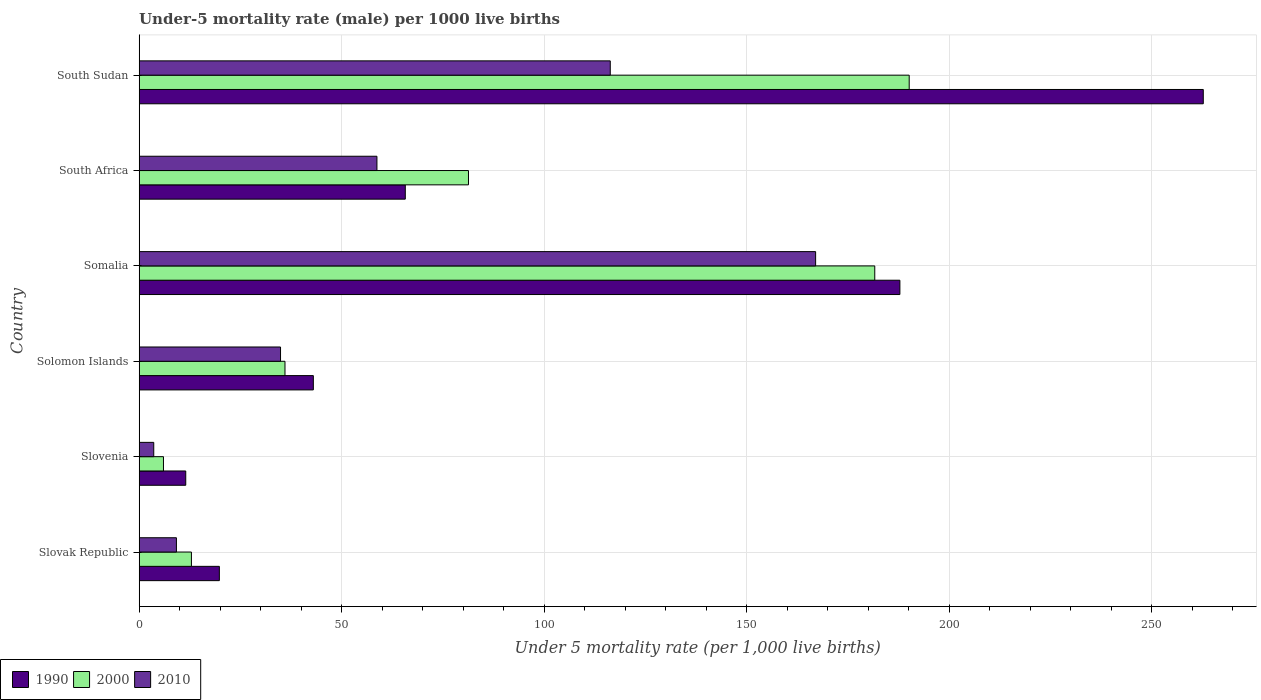How many groups of bars are there?
Offer a very short reply. 6. Are the number of bars on each tick of the Y-axis equal?
Offer a terse response. Yes. How many bars are there on the 1st tick from the top?
Offer a terse response. 3. How many bars are there on the 2nd tick from the bottom?
Offer a terse response. 3. What is the label of the 5th group of bars from the top?
Give a very brief answer. Slovenia. What is the under-five mortality rate in 2000 in Somalia?
Your response must be concise. 181.6. Across all countries, what is the maximum under-five mortality rate in 2000?
Make the answer very short. 190.1. In which country was the under-five mortality rate in 2000 maximum?
Ensure brevity in your answer.  South Sudan. In which country was the under-five mortality rate in 2010 minimum?
Offer a terse response. Slovenia. What is the total under-five mortality rate in 2010 in the graph?
Make the answer very short. 389.7. What is the difference between the under-five mortality rate in 2000 in Slovenia and that in South Sudan?
Keep it short and to the point. -184.1. What is the difference between the under-five mortality rate in 2000 in Slovak Republic and the under-five mortality rate in 1990 in South Sudan?
Your answer should be very brief. -249.8. What is the average under-five mortality rate in 1990 per country?
Your answer should be compact. 98.42. What is the difference between the under-five mortality rate in 1990 and under-five mortality rate in 2010 in Slovak Republic?
Provide a succinct answer. 10.6. What is the ratio of the under-five mortality rate in 2000 in Slovenia to that in South Sudan?
Your answer should be compact. 0.03. What is the difference between the highest and the second highest under-five mortality rate in 2010?
Your answer should be compact. 50.7. What is the difference between the highest and the lowest under-five mortality rate in 1990?
Your response must be concise. 251.2. In how many countries, is the under-five mortality rate in 1990 greater than the average under-five mortality rate in 1990 taken over all countries?
Provide a short and direct response. 2. Is the sum of the under-five mortality rate in 2000 in South Africa and South Sudan greater than the maximum under-five mortality rate in 1990 across all countries?
Offer a terse response. Yes. What does the 3rd bar from the top in Somalia represents?
Ensure brevity in your answer.  1990. How many bars are there?
Offer a terse response. 18. Are all the bars in the graph horizontal?
Provide a succinct answer. Yes. Are the values on the major ticks of X-axis written in scientific E-notation?
Keep it short and to the point. No. How many legend labels are there?
Your response must be concise. 3. How are the legend labels stacked?
Provide a succinct answer. Horizontal. What is the title of the graph?
Give a very brief answer. Under-5 mortality rate (male) per 1000 live births. Does "1962" appear as one of the legend labels in the graph?
Give a very brief answer. No. What is the label or title of the X-axis?
Make the answer very short. Under 5 mortality rate (per 1,0 live births). What is the Under 5 mortality rate (per 1,000 live births) in 1990 in Slovak Republic?
Give a very brief answer. 19.8. What is the Under 5 mortality rate (per 1,000 live births) in 2000 in Slovak Republic?
Offer a terse response. 12.9. What is the Under 5 mortality rate (per 1,000 live births) of 2010 in Slovak Republic?
Provide a succinct answer. 9.2. What is the Under 5 mortality rate (per 1,000 live births) in 1990 in Slovenia?
Your answer should be compact. 11.5. What is the Under 5 mortality rate (per 1,000 live births) in 2010 in Slovenia?
Your answer should be very brief. 3.6. What is the Under 5 mortality rate (per 1,000 live births) of 1990 in Solomon Islands?
Provide a short and direct response. 43. What is the Under 5 mortality rate (per 1,000 live births) in 2010 in Solomon Islands?
Your answer should be compact. 34.9. What is the Under 5 mortality rate (per 1,000 live births) in 1990 in Somalia?
Provide a succinct answer. 187.8. What is the Under 5 mortality rate (per 1,000 live births) of 2000 in Somalia?
Offer a very short reply. 181.6. What is the Under 5 mortality rate (per 1,000 live births) of 2010 in Somalia?
Your answer should be compact. 167. What is the Under 5 mortality rate (per 1,000 live births) of 1990 in South Africa?
Provide a short and direct response. 65.7. What is the Under 5 mortality rate (per 1,000 live births) of 2000 in South Africa?
Make the answer very short. 81.3. What is the Under 5 mortality rate (per 1,000 live births) of 2010 in South Africa?
Your answer should be compact. 58.7. What is the Under 5 mortality rate (per 1,000 live births) in 1990 in South Sudan?
Ensure brevity in your answer.  262.7. What is the Under 5 mortality rate (per 1,000 live births) of 2000 in South Sudan?
Keep it short and to the point. 190.1. What is the Under 5 mortality rate (per 1,000 live births) in 2010 in South Sudan?
Your answer should be very brief. 116.3. Across all countries, what is the maximum Under 5 mortality rate (per 1,000 live births) of 1990?
Offer a terse response. 262.7. Across all countries, what is the maximum Under 5 mortality rate (per 1,000 live births) in 2000?
Give a very brief answer. 190.1. Across all countries, what is the maximum Under 5 mortality rate (per 1,000 live births) of 2010?
Offer a terse response. 167. Across all countries, what is the minimum Under 5 mortality rate (per 1,000 live births) in 2000?
Keep it short and to the point. 6. Across all countries, what is the minimum Under 5 mortality rate (per 1,000 live births) in 2010?
Ensure brevity in your answer.  3.6. What is the total Under 5 mortality rate (per 1,000 live births) in 1990 in the graph?
Make the answer very short. 590.5. What is the total Under 5 mortality rate (per 1,000 live births) in 2000 in the graph?
Offer a very short reply. 507.9. What is the total Under 5 mortality rate (per 1,000 live births) in 2010 in the graph?
Make the answer very short. 389.7. What is the difference between the Under 5 mortality rate (per 1,000 live births) of 1990 in Slovak Republic and that in Slovenia?
Your response must be concise. 8.3. What is the difference between the Under 5 mortality rate (per 1,000 live births) of 2000 in Slovak Republic and that in Slovenia?
Keep it short and to the point. 6.9. What is the difference between the Under 5 mortality rate (per 1,000 live births) in 2010 in Slovak Republic and that in Slovenia?
Your response must be concise. 5.6. What is the difference between the Under 5 mortality rate (per 1,000 live births) in 1990 in Slovak Republic and that in Solomon Islands?
Keep it short and to the point. -23.2. What is the difference between the Under 5 mortality rate (per 1,000 live births) in 2000 in Slovak Republic and that in Solomon Islands?
Ensure brevity in your answer.  -23.1. What is the difference between the Under 5 mortality rate (per 1,000 live births) in 2010 in Slovak Republic and that in Solomon Islands?
Ensure brevity in your answer.  -25.7. What is the difference between the Under 5 mortality rate (per 1,000 live births) in 1990 in Slovak Republic and that in Somalia?
Offer a terse response. -168. What is the difference between the Under 5 mortality rate (per 1,000 live births) of 2000 in Slovak Republic and that in Somalia?
Offer a terse response. -168.7. What is the difference between the Under 5 mortality rate (per 1,000 live births) of 2010 in Slovak Republic and that in Somalia?
Ensure brevity in your answer.  -157.8. What is the difference between the Under 5 mortality rate (per 1,000 live births) of 1990 in Slovak Republic and that in South Africa?
Provide a short and direct response. -45.9. What is the difference between the Under 5 mortality rate (per 1,000 live births) of 2000 in Slovak Republic and that in South Africa?
Keep it short and to the point. -68.4. What is the difference between the Under 5 mortality rate (per 1,000 live births) of 2010 in Slovak Republic and that in South Africa?
Your answer should be very brief. -49.5. What is the difference between the Under 5 mortality rate (per 1,000 live births) in 1990 in Slovak Republic and that in South Sudan?
Your response must be concise. -242.9. What is the difference between the Under 5 mortality rate (per 1,000 live births) in 2000 in Slovak Republic and that in South Sudan?
Make the answer very short. -177.2. What is the difference between the Under 5 mortality rate (per 1,000 live births) in 2010 in Slovak Republic and that in South Sudan?
Offer a terse response. -107.1. What is the difference between the Under 5 mortality rate (per 1,000 live births) of 1990 in Slovenia and that in Solomon Islands?
Make the answer very short. -31.5. What is the difference between the Under 5 mortality rate (per 1,000 live births) of 2000 in Slovenia and that in Solomon Islands?
Your answer should be compact. -30. What is the difference between the Under 5 mortality rate (per 1,000 live births) of 2010 in Slovenia and that in Solomon Islands?
Your answer should be compact. -31.3. What is the difference between the Under 5 mortality rate (per 1,000 live births) in 1990 in Slovenia and that in Somalia?
Your response must be concise. -176.3. What is the difference between the Under 5 mortality rate (per 1,000 live births) of 2000 in Slovenia and that in Somalia?
Provide a succinct answer. -175.6. What is the difference between the Under 5 mortality rate (per 1,000 live births) in 2010 in Slovenia and that in Somalia?
Provide a short and direct response. -163.4. What is the difference between the Under 5 mortality rate (per 1,000 live births) in 1990 in Slovenia and that in South Africa?
Your response must be concise. -54.2. What is the difference between the Under 5 mortality rate (per 1,000 live births) of 2000 in Slovenia and that in South Africa?
Your response must be concise. -75.3. What is the difference between the Under 5 mortality rate (per 1,000 live births) of 2010 in Slovenia and that in South Africa?
Your response must be concise. -55.1. What is the difference between the Under 5 mortality rate (per 1,000 live births) of 1990 in Slovenia and that in South Sudan?
Keep it short and to the point. -251.2. What is the difference between the Under 5 mortality rate (per 1,000 live births) in 2000 in Slovenia and that in South Sudan?
Make the answer very short. -184.1. What is the difference between the Under 5 mortality rate (per 1,000 live births) of 2010 in Slovenia and that in South Sudan?
Your answer should be very brief. -112.7. What is the difference between the Under 5 mortality rate (per 1,000 live births) of 1990 in Solomon Islands and that in Somalia?
Make the answer very short. -144.8. What is the difference between the Under 5 mortality rate (per 1,000 live births) in 2000 in Solomon Islands and that in Somalia?
Offer a terse response. -145.6. What is the difference between the Under 5 mortality rate (per 1,000 live births) of 2010 in Solomon Islands and that in Somalia?
Ensure brevity in your answer.  -132.1. What is the difference between the Under 5 mortality rate (per 1,000 live births) in 1990 in Solomon Islands and that in South Africa?
Make the answer very short. -22.7. What is the difference between the Under 5 mortality rate (per 1,000 live births) in 2000 in Solomon Islands and that in South Africa?
Your answer should be very brief. -45.3. What is the difference between the Under 5 mortality rate (per 1,000 live births) in 2010 in Solomon Islands and that in South Africa?
Offer a terse response. -23.8. What is the difference between the Under 5 mortality rate (per 1,000 live births) in 1990 in Solomon Islands and that in South Sudan?
Give a very brief answer. -219.7. What is the difference between the Under 5 mortality rate (per 1,000 live births) in 2000 in Solomon Islands and that in South Sudan?
Offer a very short reply. -154.1. What is the difference between the Under 5 mortality rate (per 1,000 live births) in 2010 in Solomon Islands and that in South Sudan?
Your answer should be compact. -81.4. What is the difference between the Under 5 mortality rate (per 1,000 live births) of 1990 in Somalia and that in South Africa?
Ensure brevity in your answer.  122.1. What is the difference between the Under 5 mortality rate (per 1,000 live births) in 2000 in Somalia and that in South Africa?
Your response must be concise. 100.3. What is the difference between the Under 5 mortality rate (per 1,000 live births) in 2010 in Somalia and that in South Africa?
Keep it short and to the point. 108.3. What is the difference between the Under 5 mortality rate (per 1,000 live births) in 1990 in Somalia and that in South Sudan?
Offer a terse response. -74.9. What is the difference between the Under 5 mortality rate (per 1,000 live births) of 2000 in Somalia and that in South Sudan?
Offer a terse response. -8.5. What is the difference between the Under 5 mortality rate (per 1,000 live births) in 2010 in Somalia and that in South Sudan?
Provide a succinct answer. 50.7. What is the difference between the Under 5 mortality rate (per 1,000 live births) in 1990 in South Africa and that in South Sudan?
Your answer should be compact. -197. What is the difference between the Under 5 mortality rate (per 1,000 live births) in 2000 in South Africa and that in South Sudan?
Offer a terse response. -108.8. What is the difference between the Under 5 mortality rate (per 1,000 live births) of 2010 in South Africa and that in South Sudan?
Offer a terse response. -57.6. What is the difference between the Under 5 mortality rate (per 1,000 live births) in 1990 in Slovak Republic and the Under 5 mortality rate (per 1,000 live births) in 2000 in Slovenia?
Your answer should be very brief. 13.8. What is the difference between the Under 5 mortality rate (per 1,000 live births) of 1990 in Slovak Republic and the Under 5 mortality rate (per 1,000 live births) of 2000 in Solomon Islands?
Provide a short and direct response. -16.2. What is the difference between the Under 5 mortality rate (per 1,000 live births) in 1990 in Slovak Republic and the Under 5 mortality rate (per 1,000 live births) in 2010 in Solomon Islands?
Your answer should be very brief. -15.1. What is the difference between the Under 5 mortality rate (per 1,000 live births) in 2000 in Slovak Republic and the Under 5 mortality rate (per 1,000 live births) in 2010 in Solomon Islands?
Offer a terse response. -22. What is the difference between the Under 5 mortality rate (per 1,000 live births) in 1990 in Slovak Republic and the Under 5 mortality rate (per 1,000 live births) in 2000 in Somalia?
Ensure brevity in your answer.  -161.8. What is the difference between the Under 5 mortality rate (per 1,000 live births) of 1990 in Slovak Republic and the Under 5 mortality rate (per 1,000 live births) of 2010 in Somalia?
Provide a succinct answer. -147.2. What is the difference between the Under 5 mortality rate (per 1,000 live births) of 2000 in Slovak Republic and the Under 5 mortality rate (per 1,000 live births) of 2010 in Somalia?
Provide a short and direct response. -154.1. What is the difference between the Under 5 mortality rate (per 1,000 live births) in 1990 in Slovak Republic and the Under 5 mortality rate (per 1,000 live births) in 2000 in South Africa?
Give a very brief answer. -61.5. What is the difference between the Under 5 mortality rate (per 1,000 live births) of 1990 in Slovak Republic and the Under 5 mortality rate (per 1,000 live births) of 2010 in South Africa?
Make the answer very short. -38.9. What is the difference between the Under 5 mortality rate (per 1,000 live births) of 2000 in Slovak Republic and the Under 5 mortality rate (per 1,000 live births) of 2010 in South Africa?
Your answer should be very brief. -45.8. What is the difference between the Under 5 mortality rate (per 1,000 live births) in 1990 in Slovak Republic and the Under 5 mortality rate (per 1,000 live births) in 2000 in South Sudan?
Your answer should be compact. -170.3. What is the difference between the Under 5 mortality rate (per 1,000 live births) in 1990 in Slovak Republic and the Under 5 mortality rate (per 1,000 live births) in 2010 in South Sudan?
Offer a terse response. -96.5. What is the difference between the Under 5 mortality rate (per 1,000 live births) of 2000 in Slovak Republic and the Under 5 mortality rate (per 1,000 live births) of 2010 in South Sudan?
Offer a very short reply. -103.4. What is the difference between the Under 5 mortality rate (per 1,000 live births) of 1990 in Slovenia and the Under 5 mortality rate (per 1,000 live births) of 2000 in Solomon Islands?
Your response must be concise. -24.5. What is the difference between the Under 5 mortality rate (per 1,000 live births) of 1990 in Slovenia and the Under 5 mortality rate (per 1,000 live births) of 2010 in Solomon Islands?
Make the answer very short. -23.4. What is the difference between the Under 5 mortality rate (per 1,000 live births) of 2000 in Slovenia and the Under 5 mortality rate (per 1,000 live births) of 2010 in Solomon Islands?
Offer a very short reply. -28.9. What is the difference between the Under 5 mortality rate (per 1,000 live births) in 1990 in Slovenia and the Under 5 mortality rate (per 1,000 live births) in 2000 in Somalia?
Your answer should be very brief. -170.1. What is the difference between the Under 5 mortality rate (per 1,000 live births) in 1990 in Slovenia and the Under 5 mortality rate (per 1,000 live births) in 2010 in Somalia?
Give a very brief answer. -155.5. What is the difference between the Under 5 mortality rate (per 1,000 live births) of 2000 in Slovenia and the Under 5 mortality rate (per 1,000 live births) of 2010 in Somalia?
Provide a succinct answer. -161. What is the difference between the Under 5 mortality rate (per 1,000 live births) in 1990 in Slovenia and the Under 5 mortality rate (per 1,000 live births) in 2000 in South Africa?
Give a very brief answer. -69.8. What is the difference between the Under 5 mortality rate (per 1,000 live births) of 1990 in Slovenia and the Under 5 mortality rate (per 1,000 live births) of 2010 in South Africa?
Make the answer very short. -47.2. What is the difference between the Under 5 mortality rate (per 1,000 live births) in 2000 in Slovenia and the Under 5 mortality rate (per 1,000 live births) in 2010 in South Africa?
Keep it short and to the point. -52.7. What is the difference between the Under 5 mortality rate (per 1,000 live births) in 1990 in Slovenia and the Under 5 mortality rate (per 1,000 live births) in 2000 in South Sudan?
Offer a terse response. -178.6. What is the difference between the Under 5 mortality rate (per 1,000 live births) of 1990 in Slovenia and the Under 5 mortality rate (per 1,000 live births) of 2010 in South Sudan?
Make the answer very short. -104.8. What is the difference between the Under 5 mortality rate (per 1,000 live births) in 2000 in Slovenia and the Under 5 mortality rate (per 1,000 live births) in 2010 in South Sudan?
Your answer should be very brief. -110.3. What is the difference between the Under 5 mortality rate (per 1,000 live births) of 1990 in Solomon Islands and the Under 5 mortality rate (per 1,000 live births) of 2000 in Somalia?
Ensure brevity in your answer.  -138.6. What is the difference between the Under 5 mortality rate (per 1,000 live births) of 1990 in Solomon Islands and the Under 5 mortality rate (per 1,000 live births) of 2010 in Somalia?
Your answer should be very brief. -124. What is the difference between the Under 5 mortality rate (per 1,000 live births) of 2000 in Solomon Islands and the Under 5 mortality rate (per 1,000 live births) of 2010 in Somalia?
Your response must be concise. -131. What is the difference between the Under 5 mortality rate (per 1,000 live births) in 1990 in Solomon Islands and the Under 5 mortality rate (per 1,000 live births) in 2000 in South Africa?
Ensure brevity in your answer.  -38.3. What is the difference between the Under 5 mortality rate (per 1,000 live births) of 1990 in Solomon Islands and the Under 5 mortality rate (per 1,000 live births) of 2010 in South Africa?
Offer a terse response. -15.7. What is the difference between the Under 5 mortality rate (per 1,000 live births) of 2000 in Solomon Islands and the Under 5 mortality rate (per 1,000 live births) of 2010 in South Africa?
Keep it short and to the point. -22.7. What is the difference between the Under 5 mortality rate (per 1,000 live births) of 1990 in Solomon Islands and the Under 5 mortality rate (per 1,000 live births) of 2000 in South Sudan?
Offer a terse response. -147.1. What is the difference between the Under 5 mortality rate (per 1,000 live births) of 1990 in Solomon Islands and the Under 5 mortality rate (per 1,000 live births) of 2010 in South Sudan?
Your response must be concise. -73.3. What is the difference between the Under 5 mortality rate (per 1,000 live births) in 2000 in Solomon Islands and the Under 5 mortality rate (per 1,000 live births) in 2010 in South Sudan?
Offer a very short reply. -80.3. What is the difference between the Under 5 mortality rate (per 1,000 live births) in 1990 in Somalia and the Under 5 mortality rate (per 1,000 live births) in 2000 in South Africa?
Your answer should be very brief. 106.5. What is the difference between the Under 5 mortality rate (per 1,000 live births) of 1990 in Somalia and the Under 5 mortality rate (per 1,000 live births) of 2010 in South Africa?
Make the answer very short. 129.1. What is the difference between the Under 5 mortality rate (per 1,000 live births) in 2000 in Somalia and the Under 5 mortality rate (per 1,000 live births) in 2010 in South Africa?
Ensure brevity in your answer.  122.9. What is the difference between the Under 5 mortality rate (per 1,000 live births) of 1990 in Somalia and the Under 5 mortality rate (per 1,000 live births) of 2000 in South Sudan?
Ensure brevity in your answer.  -2.3. What is the difference between the Under 5 mortality rate (per 1,000 live births) in 1990 in Somalia and the Under 5 mortality rate (per 1,000 live births) in 2010 in South Sudan?
Provide a succinct answer. 71.5. What is the difference between the Under 5 mortality rate (per 1,000 live births) in 2000 in Somalia and the Under 5 mortality rate (per 1,000 live births) in 2010 in South Sudan?
Provide a short and direct response. 65.3. What is the difference between the Under 5 mortality rate (per 1,000 live births) of 1990 in South Africa and the Under 5 mortality rate (per 1,000 live births) of 2000 in South Sudan?
Provide a succinct answer. -124.4. What is the difference between the Under 5 mortality rate (per 1,000 live births) in 1990 in South Africa and the Under 5 mortality rate (per 1,000 live births) in 2010 in South Sudan?
Make the answer very short. -50.6. What is the difference between the Under 5 mortality rate (per 1,000 live births) of 2000 in South Africa and the Under 5 mortality rate (per 1,000 live births) of 2010 in South Sudan?
Provide a short and direct response. -35. What is the average Under 5 mortality rate (per 1,000 live births) of 1990 per country?
Offer a terse response. 98.42. What is the average Under 5 mortality rate (per 1,000 live births) in 2000 per country?
Give a very brief answer. 84.65. What is the average Under 5 mortality rate (per 1,000 live births) in 2010 per country?
Offer a very short reply. 64.95. What is the difference between the Under 5 mortality rate (per 1,000 live births) in 2000 and Under 5 mortality rate (per 1,000 live births) in 2010 in Slovenia?
Provide a short and direct response. 2.4. What is the difference between the Under 5 mortality rate (per 1,000 live births) of 2000 and Under 5 mortality rate (per 1,000 live births) of 2010 in Solomon Islands?
Your answer should be compact. 1.1. What is the difference between the Under 5 mortality rate (per 1,000 live births) of 1990 and Under 5 mortality rate (per 1,000 live births) of 2010 in Somalia?
Make the answer very short. 20.8. What is the difference between the Under 5 mortality rate (per 1,000 live births) in 1990 and Under 5 mortality rate (per 1,000 live births) in 2000 in South Africa?
Provide a succinct answer. -15.6. What is the difference between the Under 5 mortality rate (per 1,000 live births) in 1990 and Under 5 mortality rate (per 1,000 live births) in 2010 in South Africa?
Keep it short and to the point. 7. What is the difference between the Under 5 mortality rate (per 1,000 live births) in 2000 and Under 5 mortality rate (per 1,000 live births) in 2010 in South Africa?
Ensure brevity in your answer.  22.6. What is the difference between the Under 5 mortality rate (per 1,000 live births) of 1990 and Under 5 mortality rate (per 1,000 live births) of 2000 in South Sudan?
Your answer should be compact. 72.6. What is the difference between the Under 5 mortality rate (per 1,000 live births) of 1990 and Under 5 mortality rate (per 1,000 live births) of 2010 in South Sudan?
Offer a terse response. 146.4. What is the difference between the Under 5 mortality rate (per 1,000 live births) in 2000 and Under 5 mortality rate (per 1,000 live births) in 2010 in South Sudan?
Your answer should be very brief. 73.8. What is the ratio of the Under 5 mortality rate (per 1,000 live births) in 1990 in Slovak Republic to that in Slovenia?
Your answer should be compact. 1.72. What is the ratio of the Under 5 mortality rate (per 1,000 live births) in 2000 in Slovak Republic to that in Slovenia?
Your answer should be very brief. 2.15. What is the ratio of the Under 5 mortality rate (per 1,000 live births) in 2010 in Slovak Republic to that in Slovenia?
Keep it short and to the point. 2.56. What is the ratio of the Under 5 mortality rate (per 1,000 live births) of 1990 in Slovak Republic to that in Solomon Islands?
Offer a terse response. 0.46. What is the ratio of the Under 5 mortality rate (per 1,000 live births) of 2000 in Slovak Republic to that in Solomon Islands?
Make the answer very short. 0.36. What is the ratio of the Under 5 mortality rate (per 1,000 live births) in 2010 in Slovak Republic to that in Solomon Islands?
Provide a short and direct response. 0.26. What is the ratio of the Under 5 mortality rate (per 1,000 live births) of 1990 in Slovak Republic to that in Somalia?
Your response must be concise. 0.11. What is the ratio of the Under 5 mortality rate (per 1,000 live births) of 2000 in Slovak Republic to that in Somalia?
Give a very brief answer. 0.07. What is the ratio of the Under 5 mortality rate (per 1,000 live births) of 2010 in Slovak Republic to that in Somalia?
Keep it short and to the point. 0.06. What is the ratio of the Under 5 mortality rate (per 1,000 live births) in 1990 in Slovak Republic to that in South Africa?
Your response must be concise. 0.3. What is the ratio of the Under 5 mortality rate (per 1,000 live births) of 2000 in Slovak Republic to that in South Africa?
Ensure brevity in your answer.  0.16. What is the ratio of the Under 5 mortality rate (per 1,000 live births) of 2010 in Slovak Republic to that in South Africa?
Your response must be concise. 0.16. What is the ratio of the Under 5 mortality rate (per 1,000 live births) in 1990 in Slovak Republic to that in South Sudan?
Ensure brevity in your answer.  0.08. What is the ratio of the Under 5 mortality rate (per 1,000 live births) of 2000 in Slovak Republic to that in South Sudan?
Ensure brevity in your answer.  0.07. What is the ratio of the Under 5 mortality rate (per 1,000 live births) of 2010 in Slovak Republic to that in South Sudan?
Provide a short and direct response. 0.08. What is the ratio of the Under 5 mortality rate (per 1,000 live births) of 1990 in Slovenia to that in Solomon Islands?
Make the answer very short. 0.27. What is the ratio of the Under 5 mortality rate (per 1,000 live births) of 2000 in Slovenia to that in Solomon Islands?
Offer a very short reply. 0.17. What is the ratio of the Under 5 mortality rate (per 1,000 live births) in 2010 in Slovenia to that in Solomon Islands?
Make the answer very short. 0.1. What is the ratio of the Under 5 mortality rate (per 1,000 live births) of 1990 in Slovenia to that in Somalia?
Your answer should be compact. 0.06. What is the ratio of the Under 5 mortality rate (per 1,000 live births) in 2000 in Slovenia to that in Somalia?
Provide a succinct answer. 0.03. What is the ratio of the Under 5 mortality rate (per 1,000 live births) of 2010 in Slovenia to that in Somalia?
Your answer should be compact. 0.02. What is the ratio of the Under 5 mortality rate (per 1,000 live births) of 1990 in Slovenia to that in South Africa?
Make the answer very short. 0.17. What is the ratio of the Under 5 mortality rate (per 1,000 live births) of 2000 in Slovenia to that in South Africa?
Ensure brevity in your answer.  0.07. What is the ratio of the Under 5 mortality rate (per 1,000 live births) in 2010 in Slovenia to that in South Africa?
Make the answer very short. 0.06. What is the ratio of the Under 5 mortality rate (per 1,000 live births) in 1990 in Slovenia to that in South Sudan?
Offer a terse response. 0.04. What is the ratio of the Under 5 mortality rate (per 1,000 live births) of 2000 in Slovenia to that in South Sudan?
Ensure brevity in your answer.  0.03. What is the ratio of the Under 5 mortality rate (per 1,000 live births) in 2010 in Slovenia to that in South Sudan?
Your answer should be compact. 0.03. What is the ratio of the Under 5 mortality rate (per 1,000 live births) in 1990 in Solomon Islands to that in Somalia?
Your answer should be compact. 0.23. What is the ratio of the Under 5 mortality rate (per 1,000 live births) in 2000 in Solomon Islands to that in Somalia?
Offer a terse response. 0.2. What is the ratio of the Under 5 mortality rate (per 1,000 live births) of 2010 in Solomon Islands to that in Somalia?
Offer a terse response. 0.21. What is the ratio of the Under 5 mortality rate (per 1,000 live births) of 1990 in Solomon Islands to that in South Africa?
Provide a short and direct response. 0.65. What is the ratio of the Under 5 mortality rate (per 1,000 live births) in 2000 in Solomon Islands to that in South Africa?
Offer a terse response. 0.44. What is the ratio of the Under 5 mortality rate (per 1,000 live births) in 2010 in Solomon Islands to that in South Africa?
Ensure brevity in your answer.  0.59. What is the ratio of the Under 5 mortality rate (per 1,000 live births) in 1990 in Solomon Islands to that in South Sudan?
Keep it short and to the point. 0.16. What is the ratio of the Under 5 mortality rate (per 1,000 live births) of 2000 in Solomon Islands to that in South Sudan?
Your response must be concise. 0.19. What is the ratio of the Under 5 mortality rate (per 1,000 live births) of 2010 in Solomon Islands to that in South Sudan?
Provide a succinct answer. 0.3. What is the ratio of the Under 5 mortality rate (per 1,000 live births) of 1990 in Somalia to that in South Africa?
Offer a very short reply. 2.86. What is the ratio of the Under 5 mortality rate (per 1,000 live births) in 2000 in Somalia to that in South Africa?
Your answer should be compact. 2.23. What is the ratio of the Under 5 mortality rate (per 1,000 live births) of 2010 in Somalia to that in South Africa?
Your answer should be very brief. 2.85. What is the ratio of the Under 5 mortality rate (per 1,000 live births) of 1990 in Somalia to that in South Sudan?
Make the answer very short. 0.71. What is the ratio of the Under 5 mortality rate (per 1,000 live births) in 2000 in Somalia to that in South Sudan?
Keep it short and to the point. 0.96. What is the ratio of the Under 5 mortality rate (per 1,000 live births) of 2010 in Somalia to that in South Sudan?
Offer a terse response. 1.44. What is the ratio of the Under 5 mortality rate (per 1,000 live births) in 1990 in South Africa to that in South Sudan?
Provide a short and direct response. 0.25. What is the ratio of the Under 5 mortality rate (per 1,000 live births) of 2000 in South Africa to that in South Sudan?
Your answer should be compact. 0.43. What is the ratio of the Under 5 mortality rate (per 1,000 live births) of 2010 in South Africa to that in South Sudan?
Your answer should be compact. 0.5. What is the difference between the highest and the second highest Under 5 mortality rate (per 1,000 live births) of 1990?
Your response must be concise. 74.9. What is the difference between the highest and the second highest Under 5 mortality rate (per 1,000 live births) in 2000?
Provide a short and direct response. 8.5. What is the difference between the highest and the second highest Under 5 mortality rate (per 1,000 live births) in 2010?
Keep it short and to the point. 50.7. What is the difference between the highest and the lowest Under 5 mortality rate (per 1,000 live births) in 1990?
Keep it short and to the point. 251.2. What is the difference between the highest and the lowest Under 5 mortality rate (per 1,000 live births) in 2000?
Provide a short and direct response. 184.1. What is the difference between the highest and the lowest Under 5 mortality rate (per 1,000 live births) of 2010?
Make the answer very short. 163.4. 